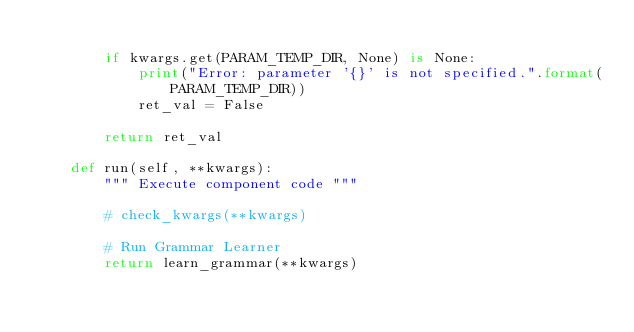Convert code to text. <code><loc_0><loc_0><loc_500><loc_500><_Python_>
        if kwargs.get(PARAM_TEMP_DIR, None) is None:
            print("Error: parameter '{}' is not specified.".format(PARAM_TEMP_DIR))
            ret_val = False

        return ret_val

    def run(self, **kwargs):
        """ Execute component code """

        # check_kwargs(**kwargs)

        # Run Grammar Learner
        return learn_grammar(**kwargs)
</code> 